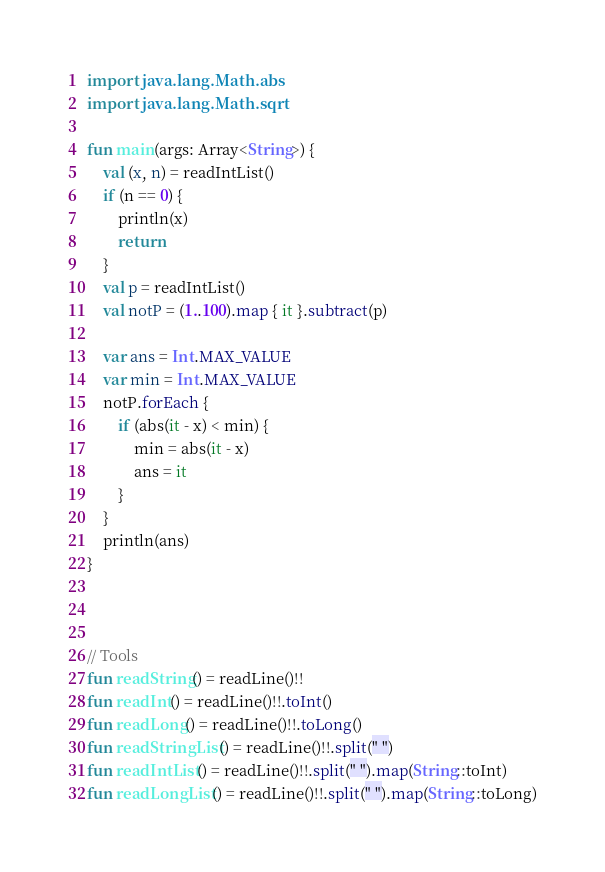Convert code to text. <code><loc_0><loc_0><loc_500><loc_500><_Kotlin_>import java.lang.Math.abs
import java.lang.Math.sqrt

fun main(args: Array<String>) {
    val (x, n) = readIntList()
    if (n == 0) {
        println(x)
        return
    }
    val p = readIntList()
    val notP = (1..100).map { it }.subtract(p)

    var ans = Int.MAX_VALUE
    var min = Int.MAX_VALUE
    notP.forEach {
        if (abs(it - x) < min) {
            min = abs(it - x)
            ans = it
        }
    }
    println(ans)
}



// Tools
fun readString() = readLine()!!
fun readInt() = readLine()!!.toInt()
fun readLong() = readLine()!!.toLong()
fun readStringList() = readLine()!!.split(" ")
fun readIntList() = readLine()!!.split(" ").map(String::toInt)
fun readLongList() = readLine()!!.split(" ").map(String::toLong)</code> 